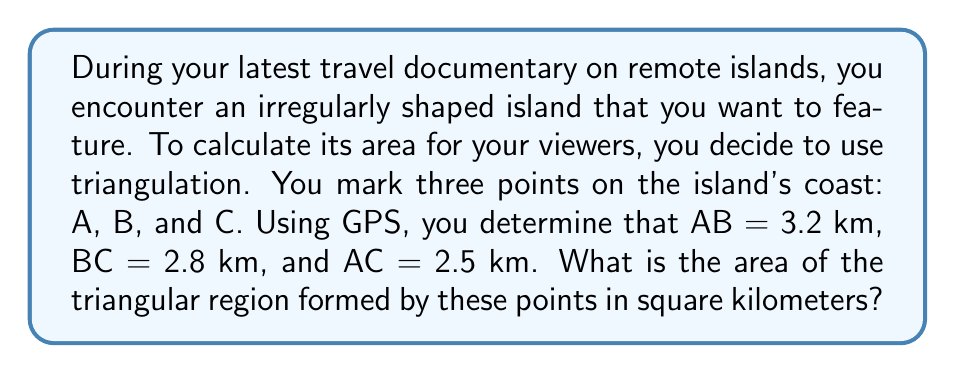Can you solve this math problem? To find the area of the triangular region, we can use Heron's formula. Let's follow these steps:

1) Heron's formula states that the area of a triangle with sides $a$, $b$, and $c$ is:

   $$A = \sqrt{s(s-a)(s-b)(s-c)}$$

   where $s$ is the semi-perimeter: $s = \frac{a+b+c}{2}$

2) In our case:
   $a = 3.2$ km (AB)
   $b = 2.8$ km (BC)
   $c = 2.5$ km (AC)

3) Calculate the semi-perimeter $s$:
   $$s = \frac{3.2 + 2.8 + 2.5}{2} = \frac{8.5}{2} = 4.25$$ km

4) Now, let's substitute these values into Heron's formula:

   $$A = \sqrt{4.25(4.25-3.2)(4.25-2.8)(4.25-2.5)}$$

5) Simplify:
   $$A = \sqrt{4.25 \cdot 1.05 \cdot 1.45 \cdot 1.75}$$

6) Calculate:
   $$A = \sqrt{11.2840625} \approx 3.3592$$ sq km

Therefore, the area of the triangular region is approximately 3.3592 square kilometers.
Answer: $3.3592$ sq km 